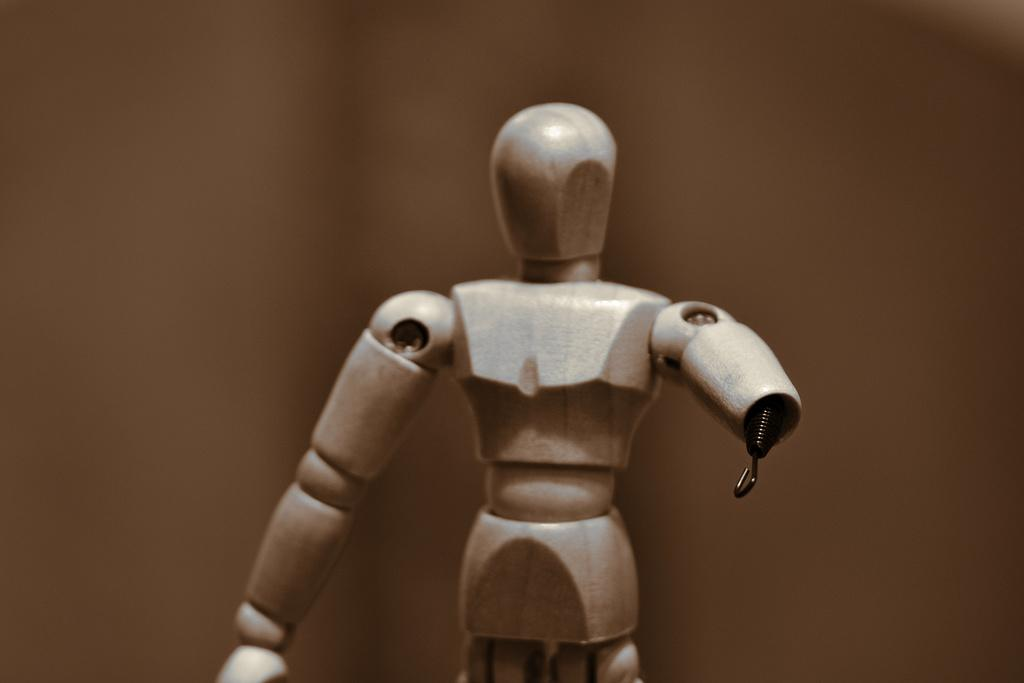What type of object is present in the image? There is a toy of a person in the image. Can you describe the toy in more detail? The toy is a representation of a person, but the specific details of the toy cannot be determined from the image alone. Where is the fork located in the image? There is no fork present in the image; it only features a toy of a person. What country is depicted in the image? The image does not depict any specific country; it only features a toy of a person. 